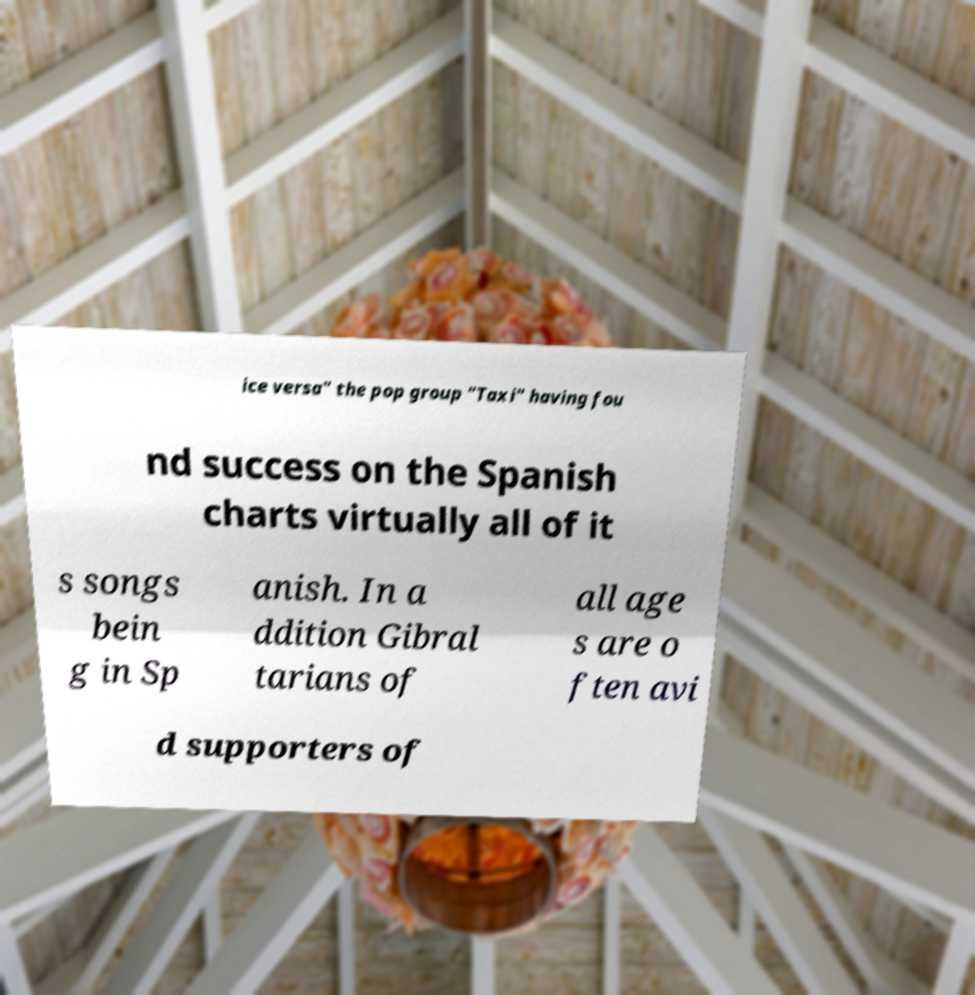Could you assist in decoding the text presented in this image and type it out clearly? ice versa" the pop group "Taxi" having fou nd success on the Spanish charts virtually all of it s songs bein g in Sp anish. In a ddition Gibral tarians of all age s are o ften avi d supporters of 